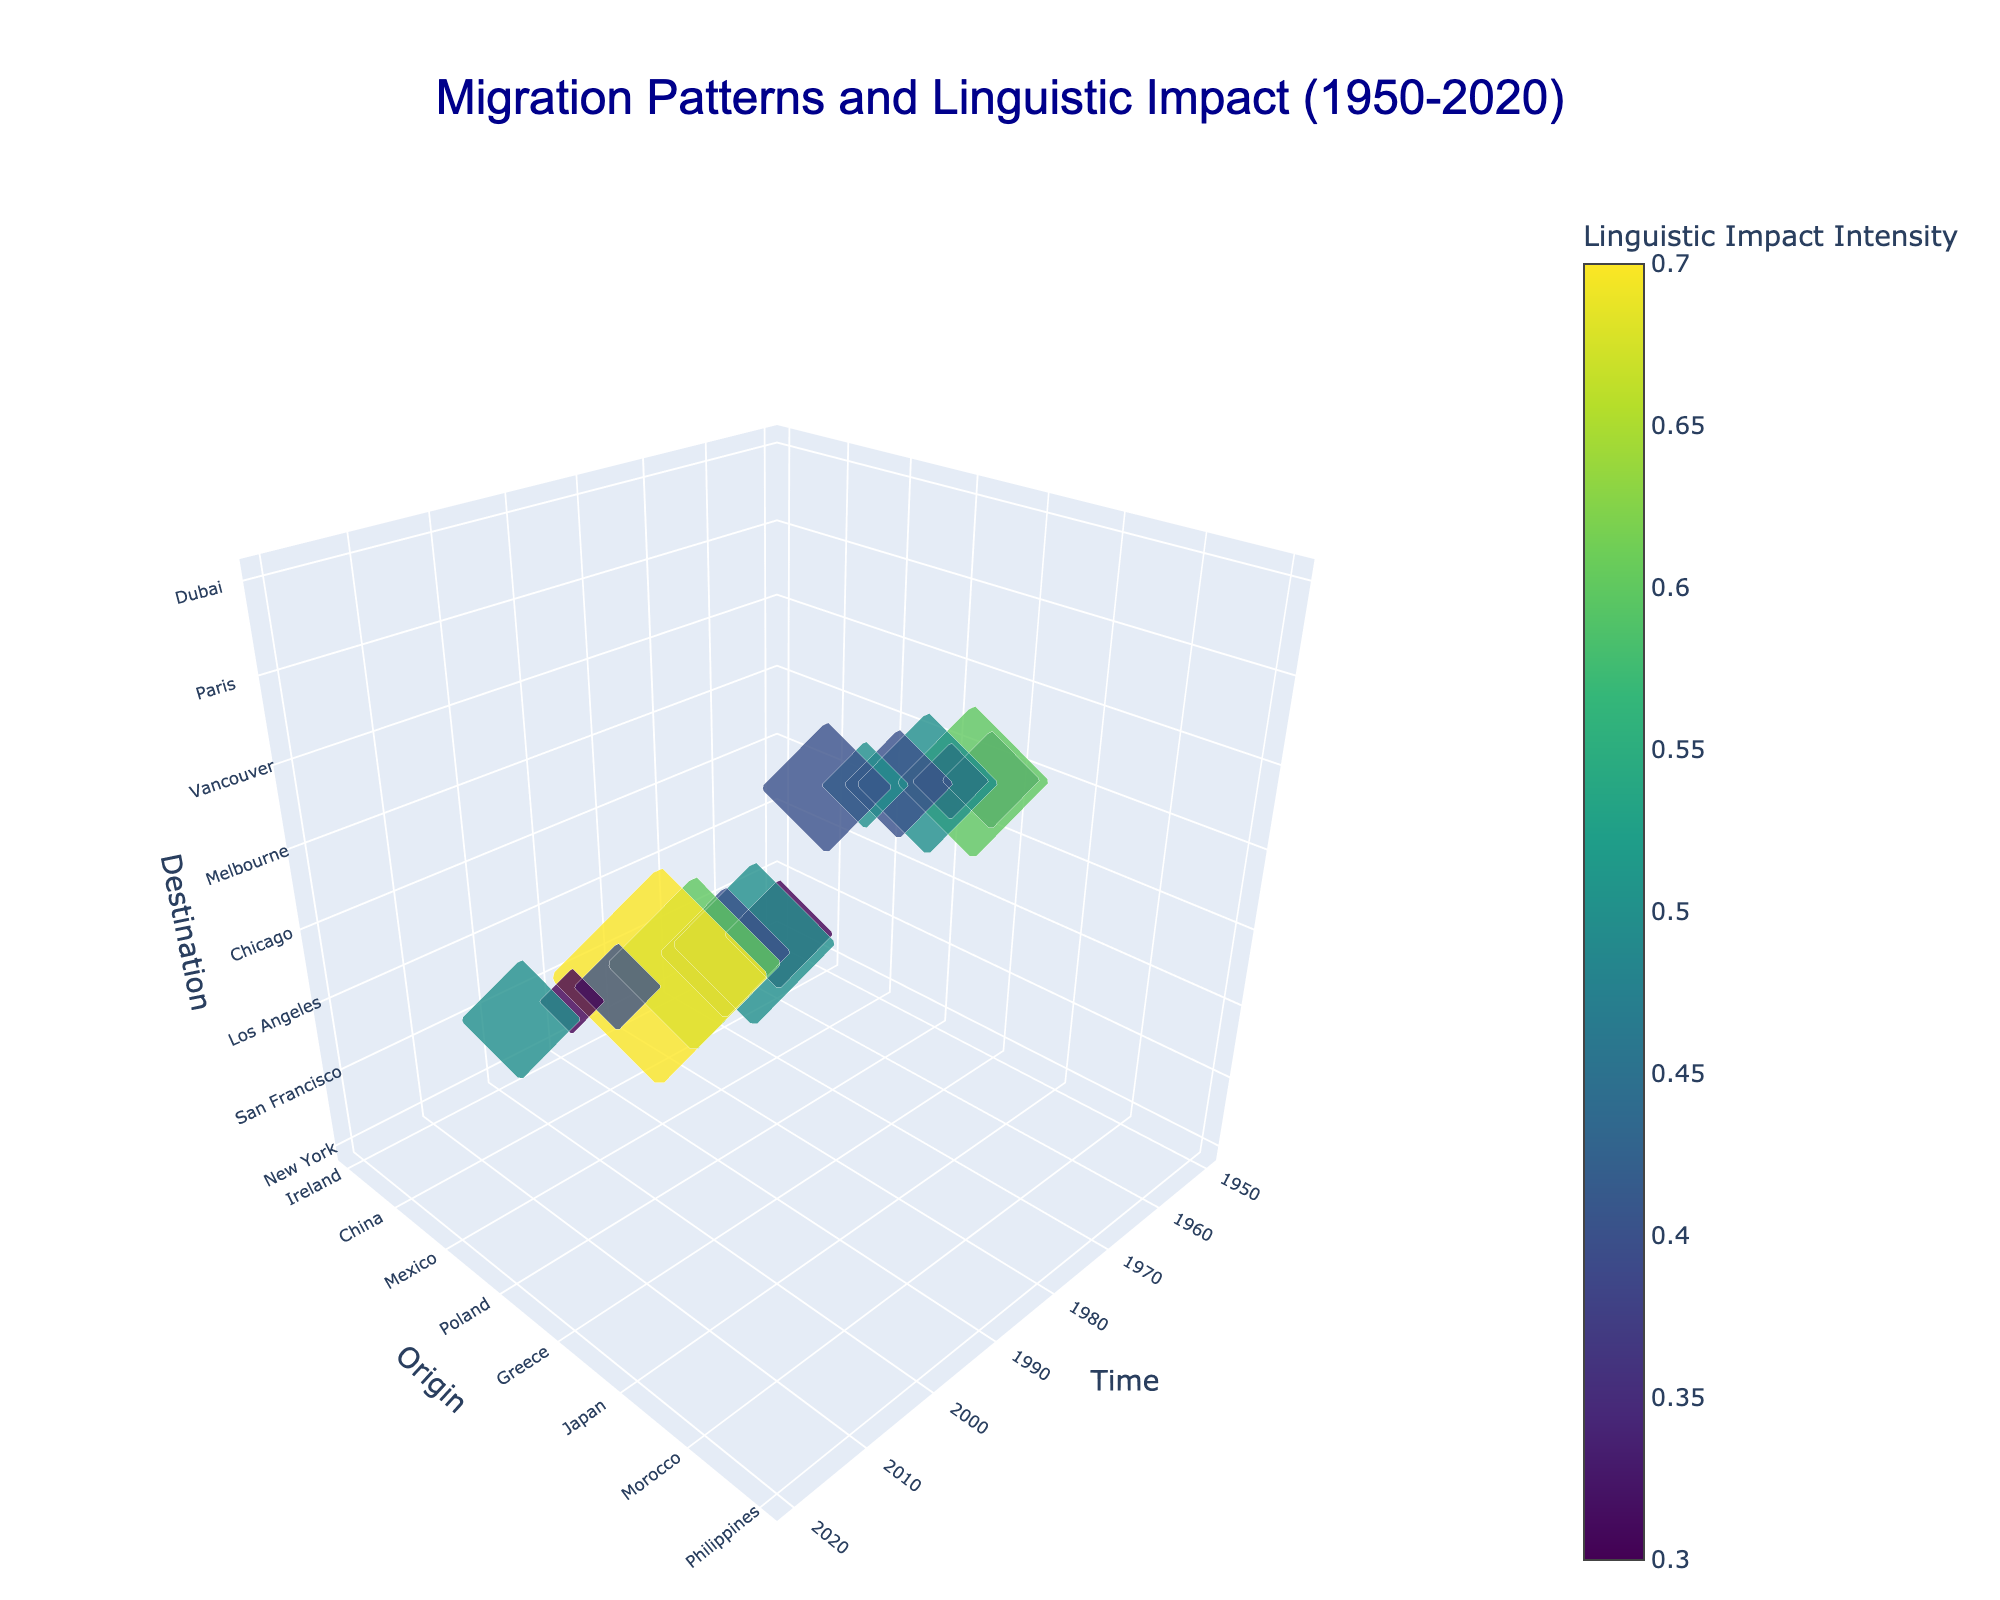What is the title of the figure? The title of the figure is located at the top. It reads "Migration Patterns and Linguistic Impact (1950-2020)".
Answer: Migration Patterns and Linguistic Impact (1950-2020) What do the axes represent? The x-axis represents Time, the y-axis represents the Origin of migration, and the z-axis represents the Destination of migration. This can be inferred from the axis labels on the plot.
Answer: Time, Origin, Destination Which migration event has the highest population? To determine this, we need to locate the scatter point on the 3D plot with the largest marker. The marker representing the Mexico to Los Angeles migration in 1990 is the largest one.
Answer: Mexico to Los Angeles in 1990 What color scale is used to represent the intensity of linguistic features? The color scale labeled "Viridis" is indicated in the context of intensity in the description and can be seen in the color bar on the right of the plot.
Answer: Viridis Which migration event has the highest linguistic intensity? By looking at the color intensity on the scatter points, the Mexico to Los Angeles migration in 1990 shows the highest intensity with a value of 0.7 represented by the darkest color.
Answer: Mexico to Los Angeles in 1990 Which period has the most migrations? Counting the number of scatter points within each decade on the time (x-axis), the period from 1950-1960 has the most migrations.
Answer: 1950-1960 Compare the linguistic intensity between the Vietnam to Sydney migration in 2000 and the Philippines to Dubai migration in 2015. By examining the color intensity for both events, the Vietnam to Sydney migration in 2000 has an intensity of 0.4, while the Philippines to Dubai migration in 2015 has an intensity of 0.4 also. They have equal intensities.
Answer: Equal (0.4) What is the average population size for migrations from Italy to Buenos Aires (1960) and India to London (1980)? To find the average, sum the population sizes of these migrations: 75000 (Italy to Buenos Aires) + 80000 (India to London) = 155000. Divide by 2 for the average: 155000 / 2 = 77500.
Answer: 77500 Which linguistic feature is observed with the migration from Turkey to Berlin in 1985? Hovering or checking the scatter point at this event shows the linguistic feature associated is Vowel harmony.
Answer: Vowel harmony Which migration event to New York has the specific linguistic feature 'R-dropping'? By examining the data for the origin, destination, and linguistic feature, the Ireland to New York migration in 1950 has 'R-dropping'.
Answer: Ireland to New York in 1950 